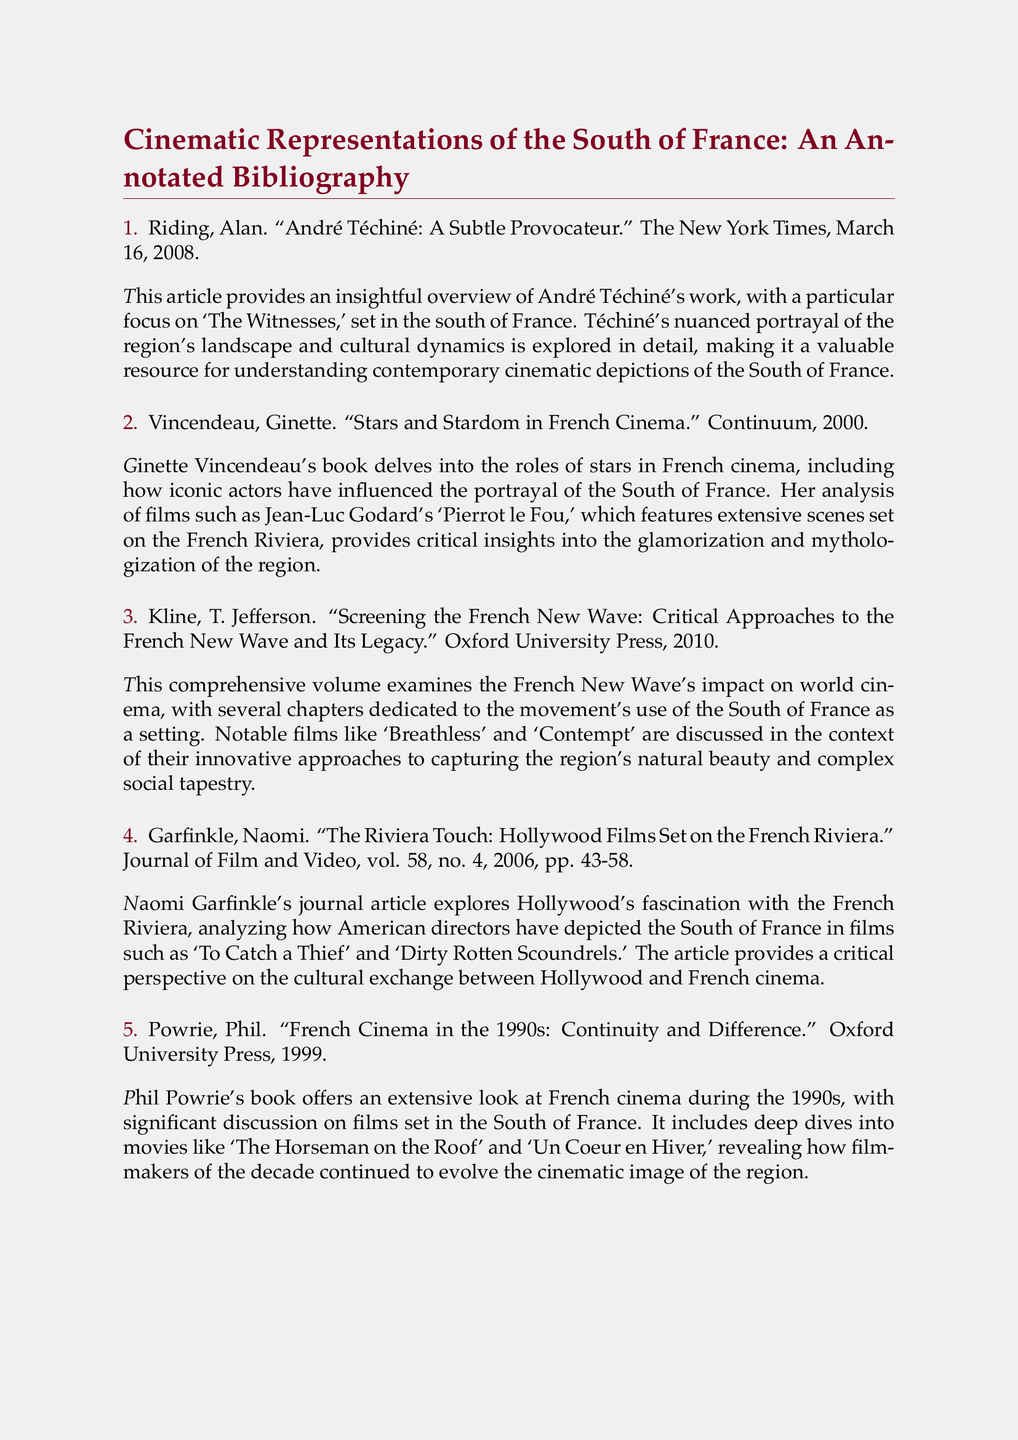what is the title of the first entry? The title of the first entry is indicated directly in the document as "André Téchiné: A Subtle Provocateur."
Answer: André Téchiné: A Subtle Provocateur who is the author of the fourth entry? The author's name is mentioned at the beginning of the fourth entry in the document.
Answer: Naomi Garfinkle what film is analyzed in the second entry? The film discussed in the second entry is specified within the text of the annotation.
Answer: Pierrot le Fou how many entries are listed in total? The total number of entries is represented by the count of items in the enumeration format.
Answer: Five which publication featured the article by Alan Riding? The publication name for Alan Riding's article is explicitly mentioned in the bibliographic entry.
Answer: The New York Times what year was "French Cinema in the 1990s: Continuity and Difference" published? The year of publication is stated within the bibliographic entry for this book.
Answer: 1999 which cinematic movement is discussed in T. Jefferson Kline's book? The movement is specified in the title, giving a clear indication of the subject matter.
Answer: French New Wave what region is predominantly depicted in the films discussed in this bibliography? The region is frequently referenced in the titles and annotations throughout the document.
Answer: South of France 